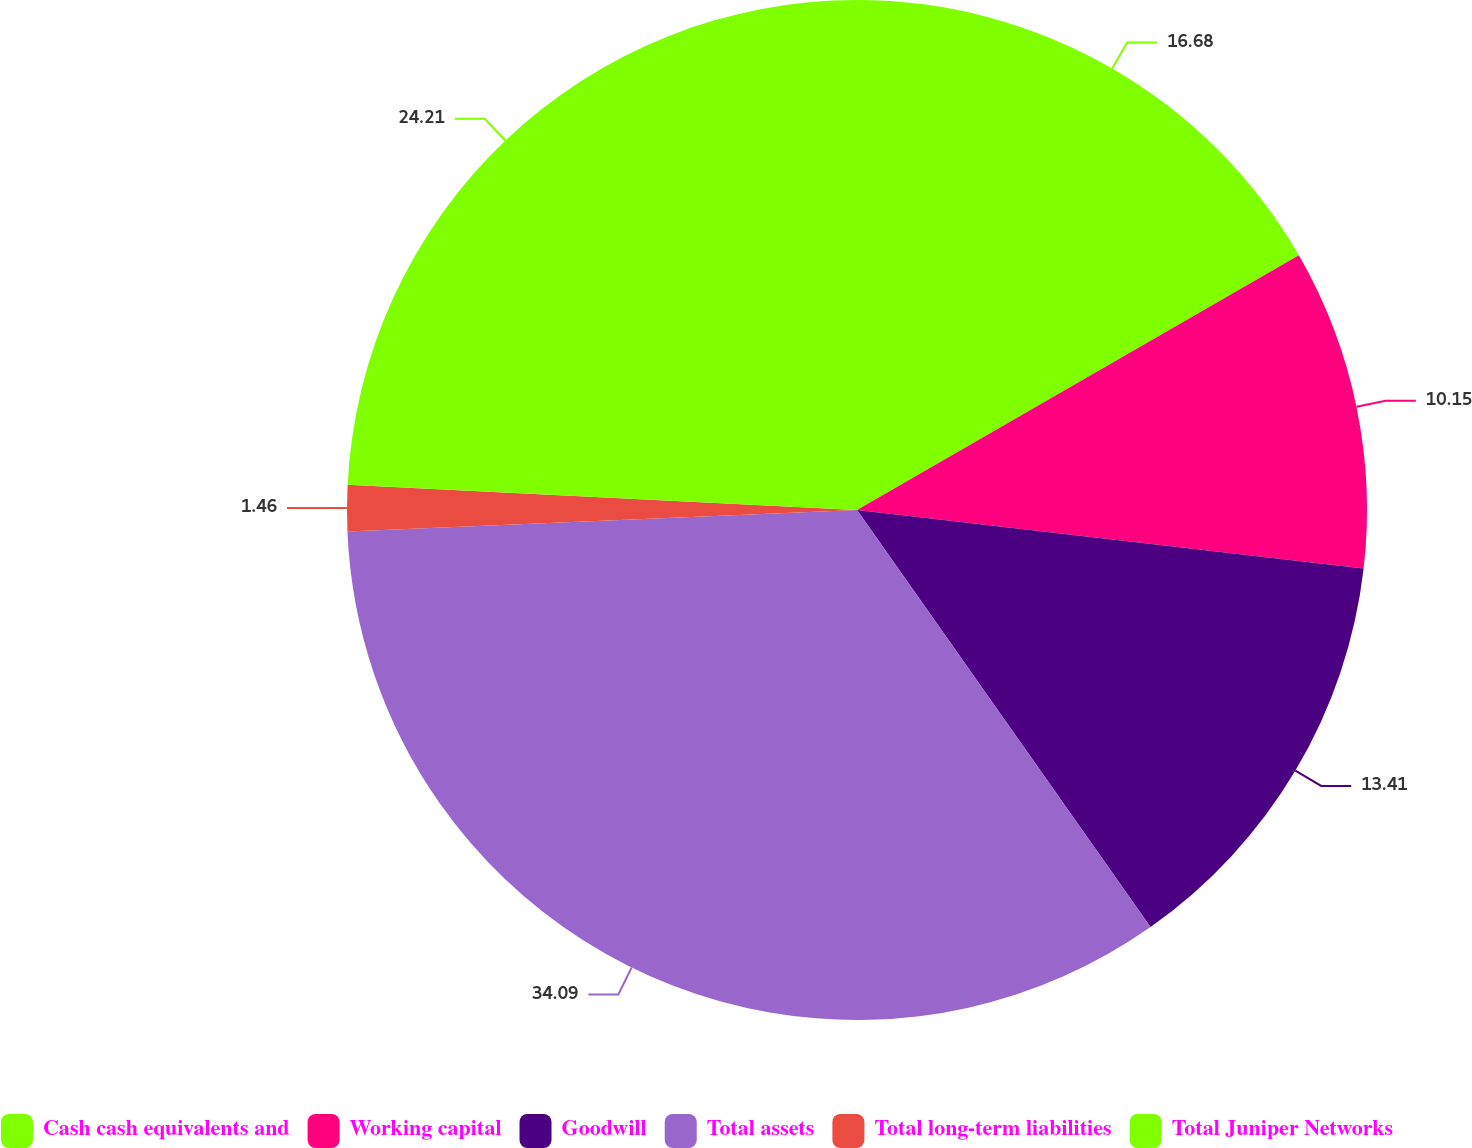Convert chart to OTSL. <chart><loc_0><loc_0><loc_500><loc_500><pie_chart><fcel>Cash cash equivalents and<fcel>Working capital<fcel>Goodwill<fcel>Total assets<fcel>Total long-term liabilities<fcel>Total Juniper Networks<nl><fcel>16.68%<fcel>10.15%<fcel>13.41%<fcel>34.09%<fcel>1.46%<fcel>24.21%<nl></chart> 